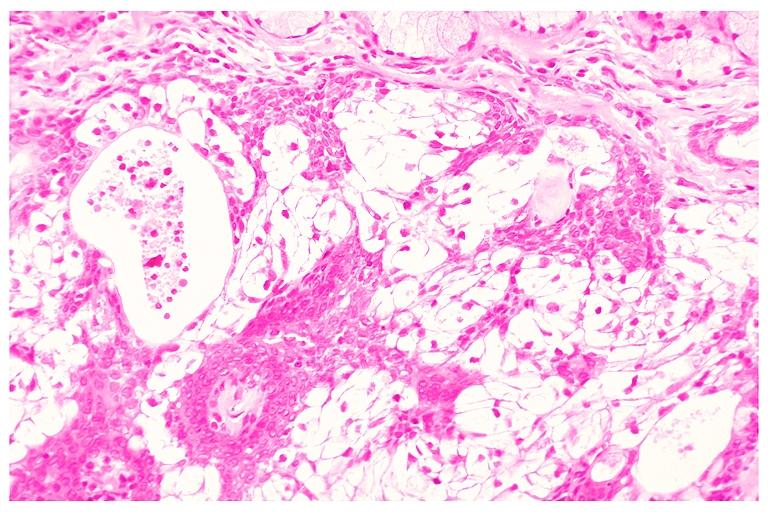what is present?
Answer the question using a single word or phrase. Oral 